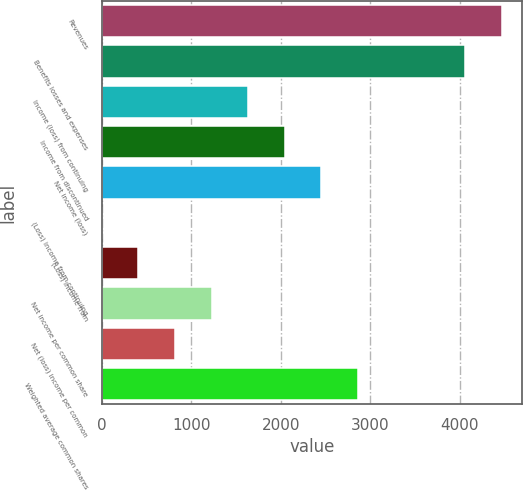Convert chart to OTSL. <chart><loc_0><loc_0><loc_500><loc_500><bar_chart><fcel>Revenues<fcel>Benefits losses and expenses<fcel>Income (loss) from continuing<fcel>Income from discontinued<fcel>Net income (loss)<fcel>(Loss) income from continuing<fcel>(Loss) income from<fcel>Net income per common share<fcel>Net (loss) income per common<fcel>Weighted average common shares<nl><fcel>4468.48<fcel>4060<fcel>1634.16<fcel>2042.64<fcel>2451.12<fcel>0.25<fcel>408.73<fcel>1225.68<fcel>817.21<fcel>2859.59<nl></chart> 